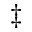Convert formula to latex. <formula><loc_0><loc_0><loc_500><loc_500>^ { \ddagger }</formula> 